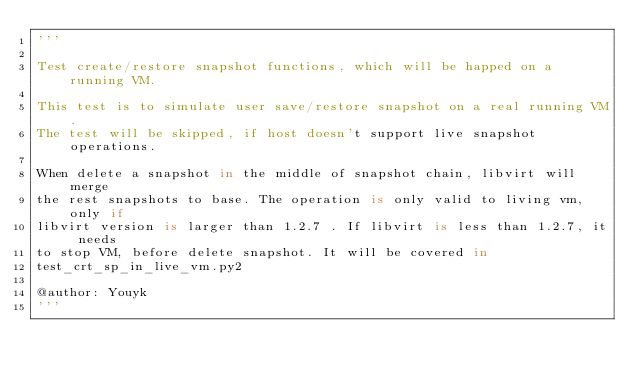Convert code to text. <code><loc_0><loc_0><loc_500><loc_500><_Python_>'''

Test create/restore snapshot functions, which will be happed on a running VM. 

This test is to simulate user save/restore snapshot on a real running VM. 
The test will be skipped, if host doesn't support live snapshot operations.

When delete a snapshot in the middle of snapshot chain, libvirt will merge
the rest snapshots to base. The operation is only valid to living vm, only if 
libvirt version is larger than 1.2.7 . If libvirt is less than 1.2.7, it needs
to stop VM, before delete snapshot. It will be covered in 
test_crt_sp_in_live_vm.py2

@author: Youyk
'''</code> 